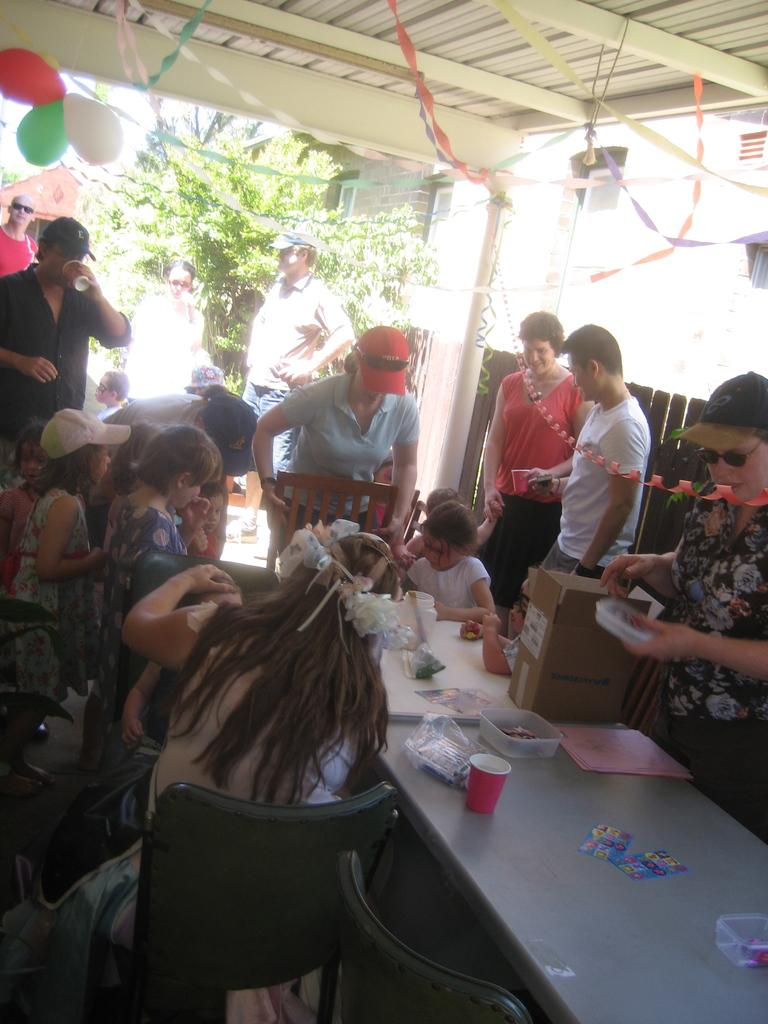What is happening with the group of people in the image? The people are enjoying food in the image. Can you describe the setting of the image? There is a tree and a building in the background of the image, and the weather is sunny. What type of silk is draped over the foot of the person in the image? There is no silk or person with a foot visible in the image. What kind of flesh can be seen on the tree in the background? There is no flesh visible on the tree in the background of the image. 